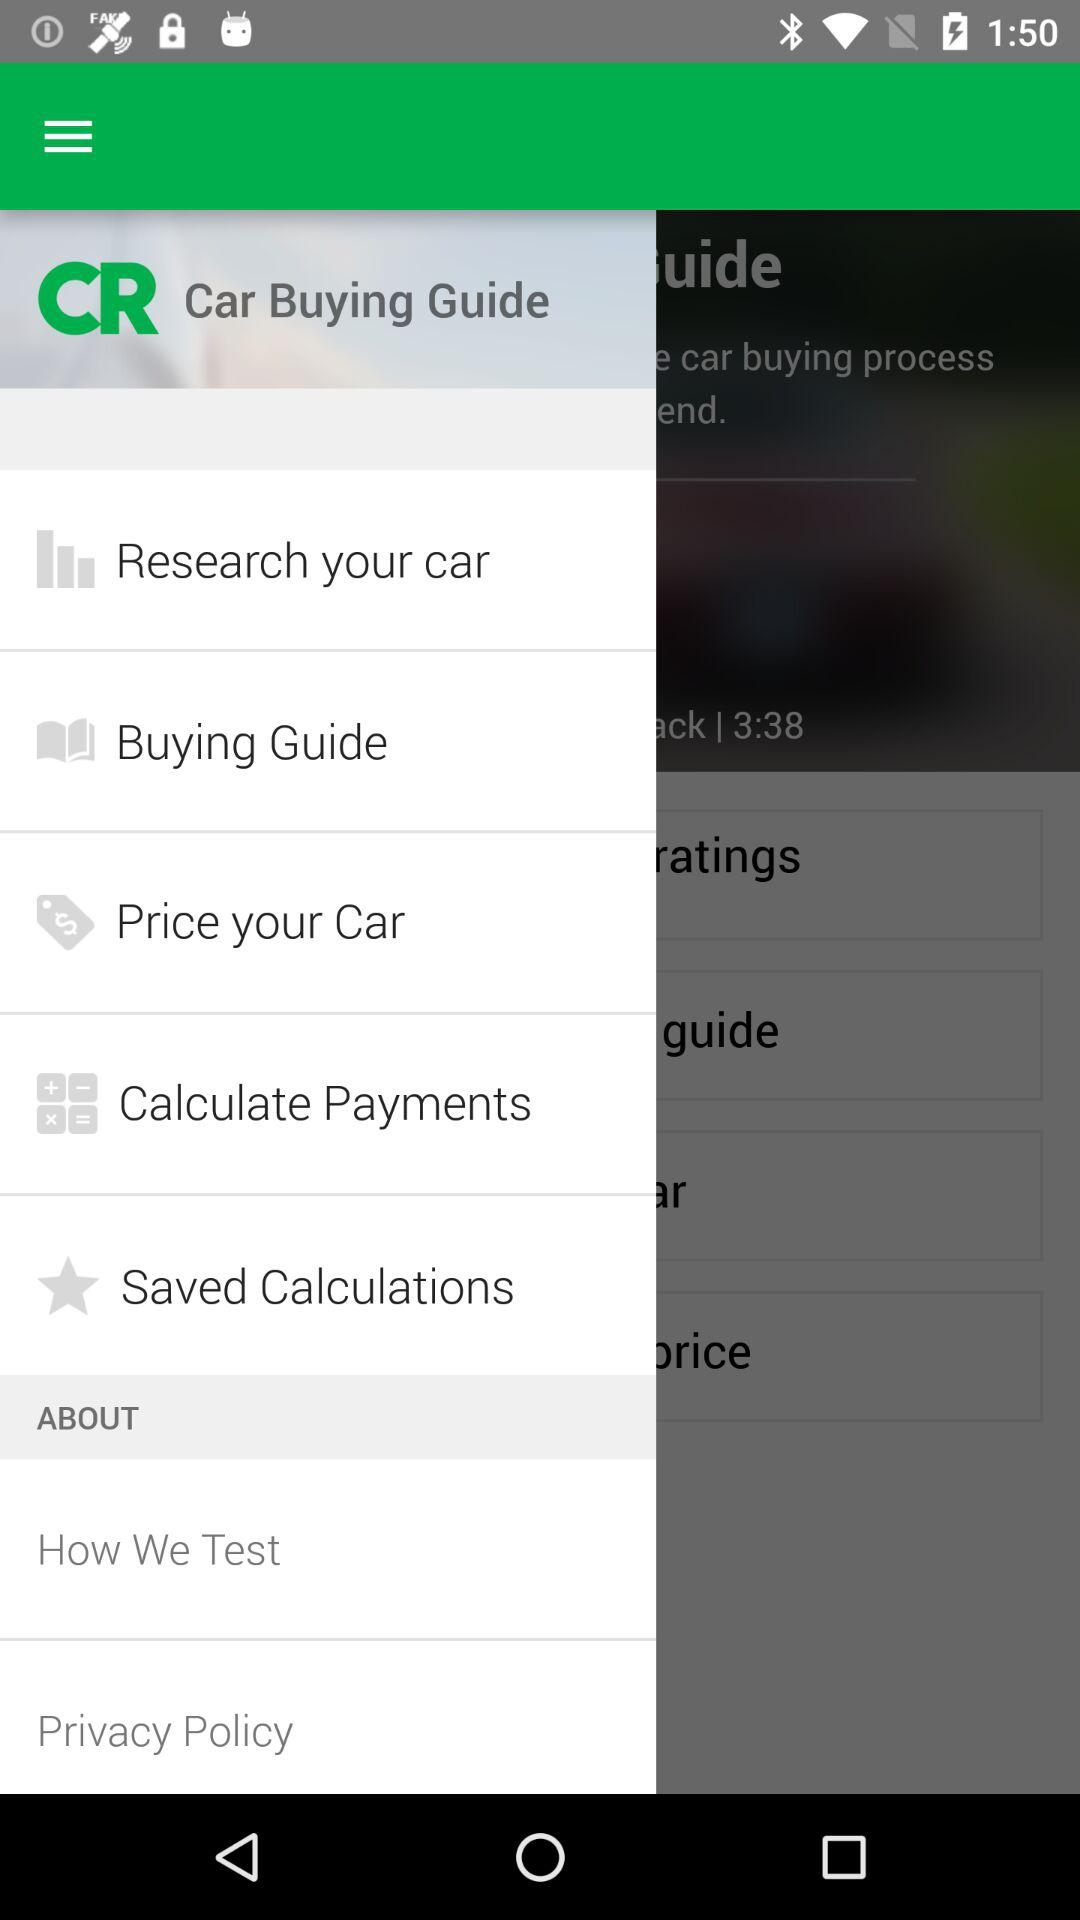What is the application name? The application name is "Car Buying Guide". 